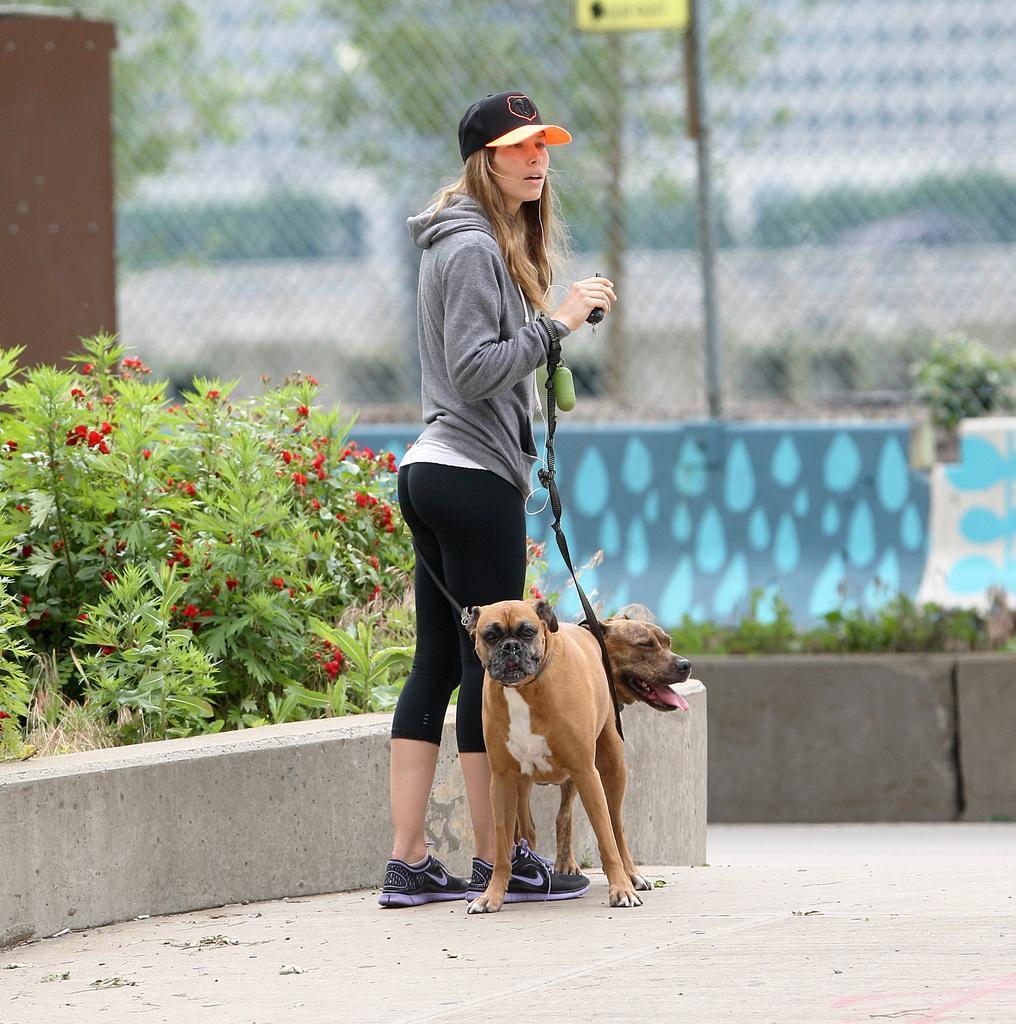Describe this image in one or two sentences. In this image in the center there is a woman standing and there are dogs. On the left side of the women there are plants. In the background there is grass and there is a wall, on the top of the wall there is fence behind the fence there are trees and there are buildings. 